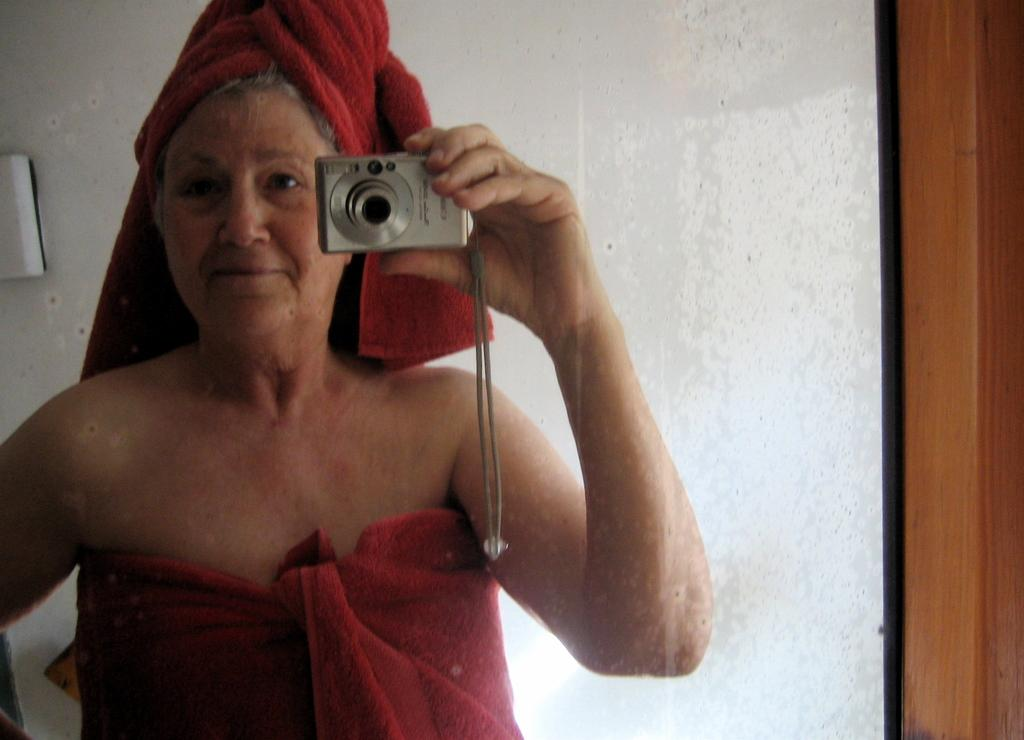What is the main subject of the image? There is a person standing in the image. What is the person wearing? The person is wearing a red dress. What is the person holding in the image? The person is holding a camera. What is the color of the background in the image? The background of the image is white. How many icicles can be seen hanging from the person's red dress in the image? There are no icicles present in the image; the person is wearing a red dress in a white background. 